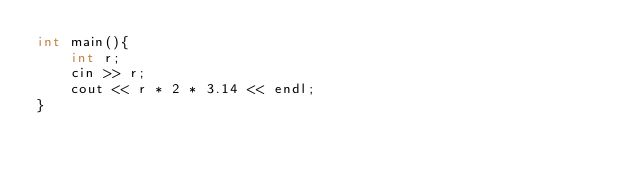<code> <loc_0><loc_0><loc_500><loc_500><_C_>int main(){
    int r;
    cin >> r;
    cout << r * 2 * 3.14 << endl;
}</code> 